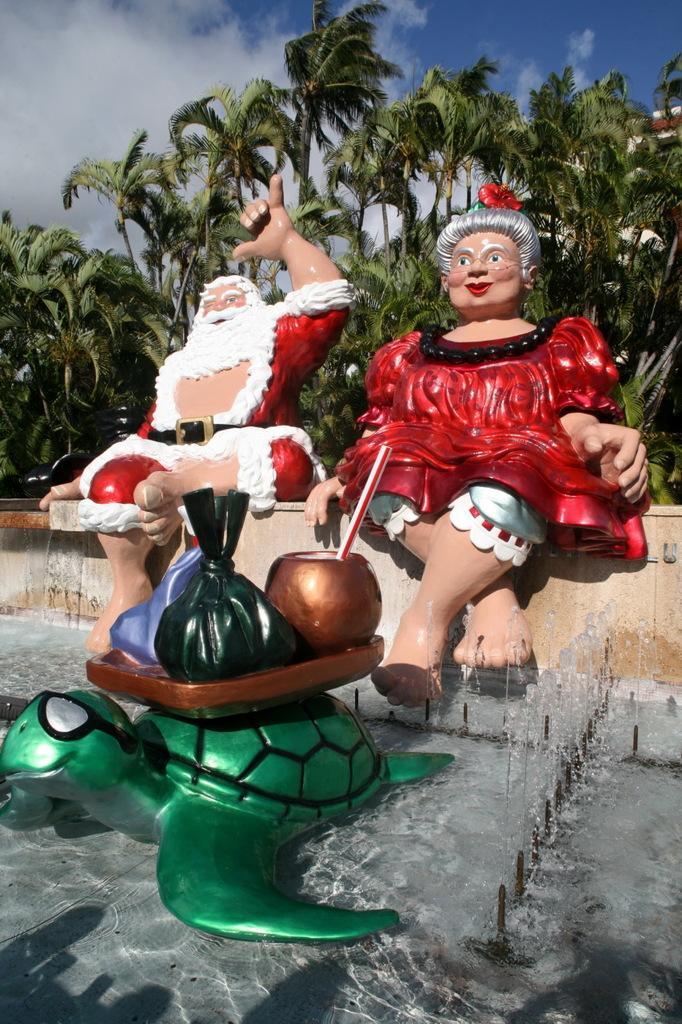How would you summarize this image in a sentence or two? In the foreground of the picture there is a fountain. In the fountain there is a catalog of tortoise and other objects. In the center of the picture there are sculptures of Santa Claus and a woman. In the background there are trees and a building. 